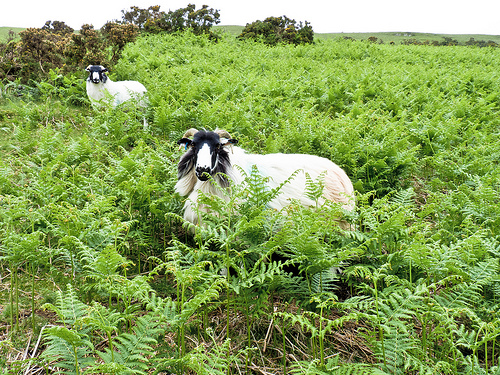Please provide a short description for this region: [0.32, 0.37, 0.49, 0.53]. This close-up shows a goat's face marked by a captivating pattern of black and white, offering a glimpse into the distinct genetic traits of the species. 